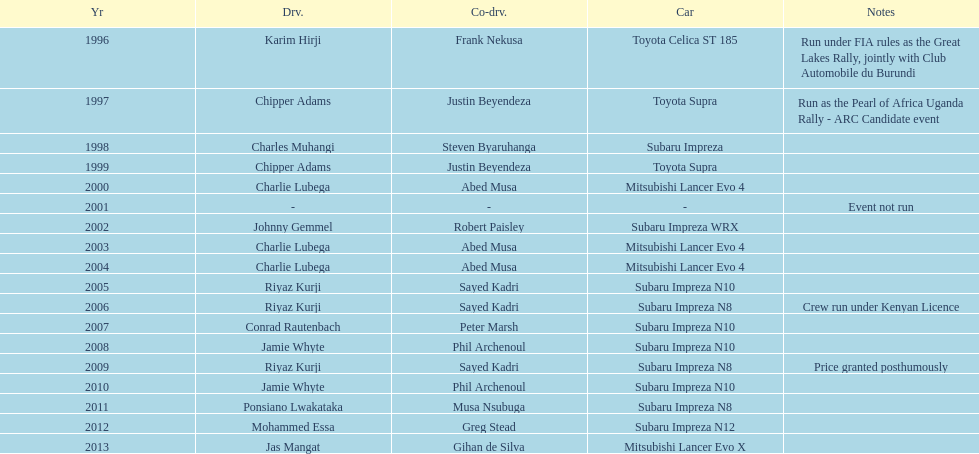What is the total number of times that the winning driver was driving a toyota supra? 2. 